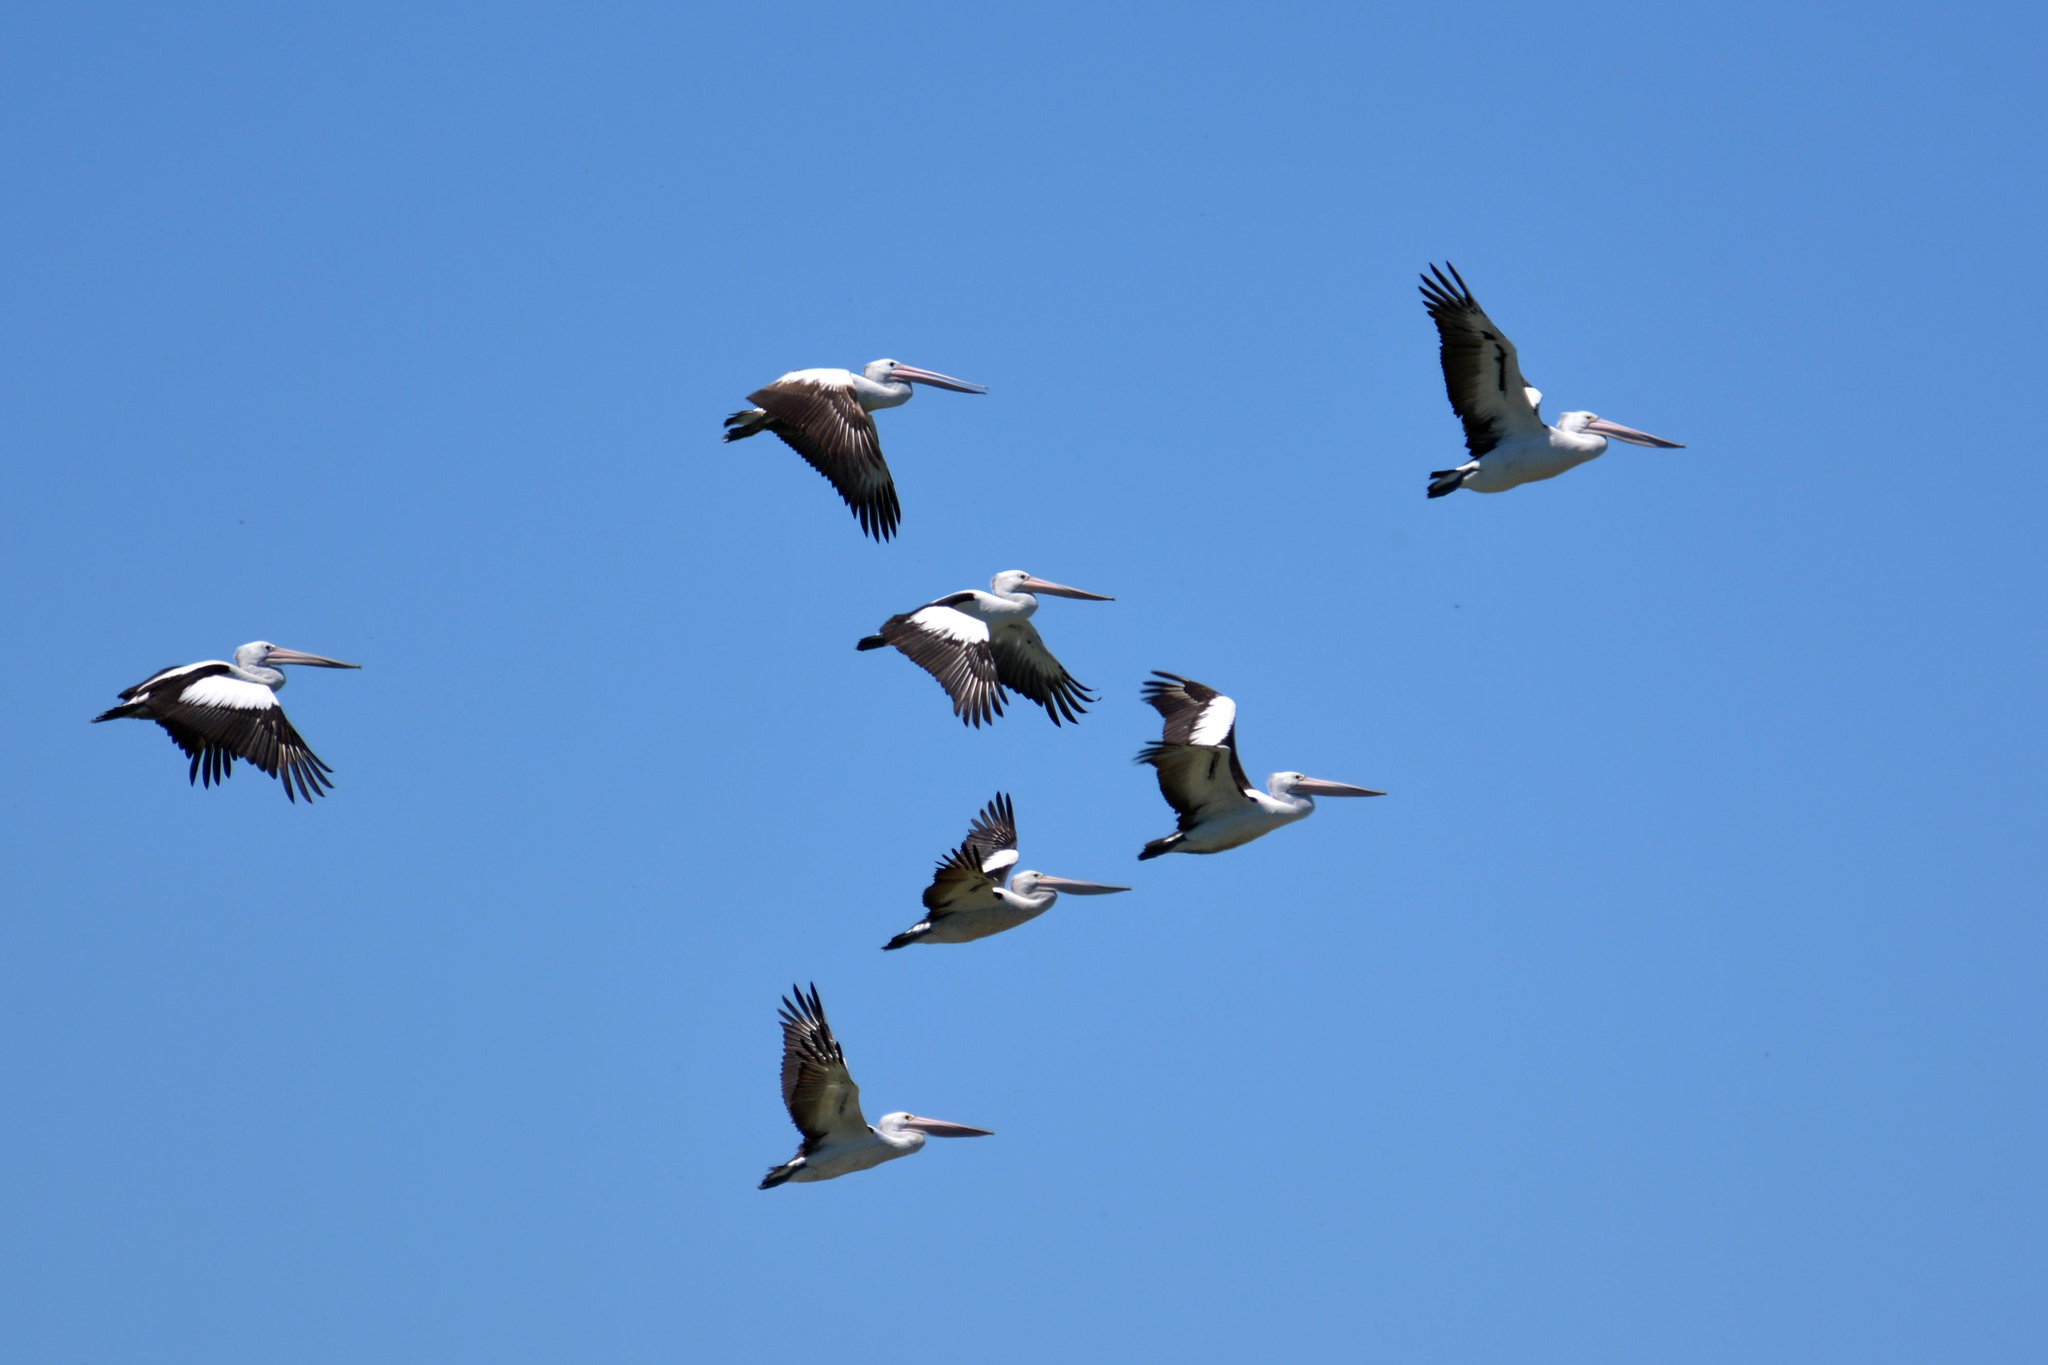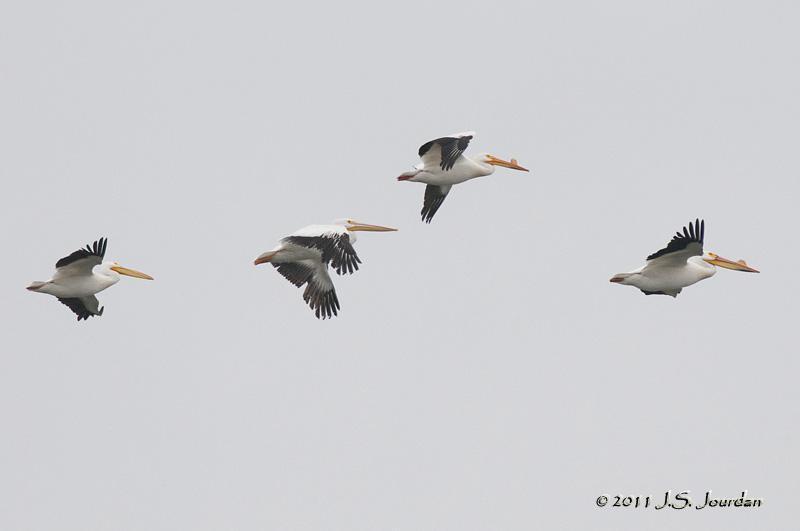The first image is the image on the left, the second image is the image on the right. For the images shown, is this caption "A single bird is flying in the image on the left." true? Answer yes or no. No. The first image is the image on the left, the second image is the image on the right. Examine the images to the left and right. Is the description "A single dark pelican flying with outspread wings is in the foreground of the left image, and the right image shows at least 10 pelicans flying leftward." accurate? Answer yes or no. No. 